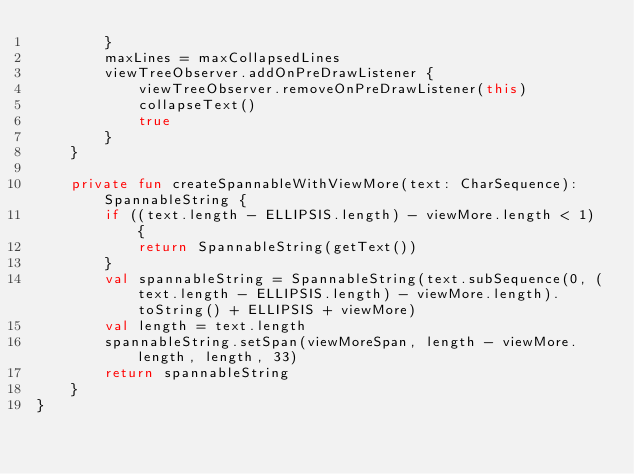Convert code to text. <code><loc_0><loc_0><loc_500><loc_500><_Kotlin_>        }
        maxLines = maxCollapsedLines
        viewTreeObserver.addOnPreDrawListener {
            viewTreeObserver.removeOnPreDrawListener(this)
            collapseText()
            true
        }
    }

    private fun createSpannableWithViewMore(text: CharSequence): SpannableString {
        if ((text.length - ELLIPSIS.length) - viewMore.length < 1) {
            return SpannableString(getText())
        }
        val spannableString = SpannableString(text.subSequence(0, (text.length - ELLIPSIS.length) - viewMore.length).toString() + ELLIPSIS + viewMore)
        val length = text.length
        spannableString.setSpan(viewMoreSpan, length - viewMore.length, length, 33)
        return spannableString
    }
}</code> 